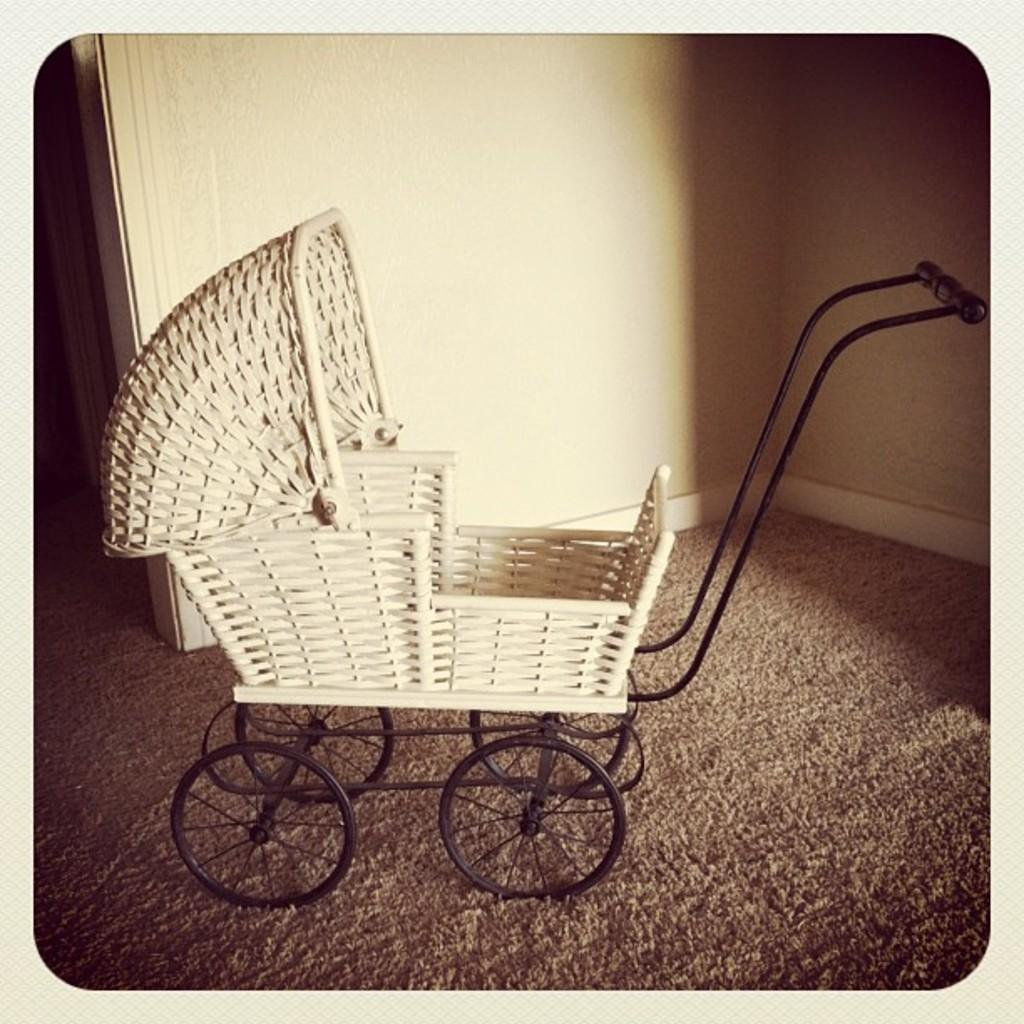What is the main subject of the photo in the image? The main subject of the photo in the image is a baby cart. What features does the baby cart have? The baby cart has wheels and a handle. Where is the baby cart located in the photo? The baby cart is on a surface in the photo. What can be seen in the background of the photo? There is a wall in the background of the photo. How much debt is associated with the baby cart in the image? There is no information about debt in the image, as it features a photo of a baby cart with wheels and a handle. Can you tell me how many grains of sand are visible in the image? There is no sand present in the image; it features a photo of a baby cart with wheels and a handle. 